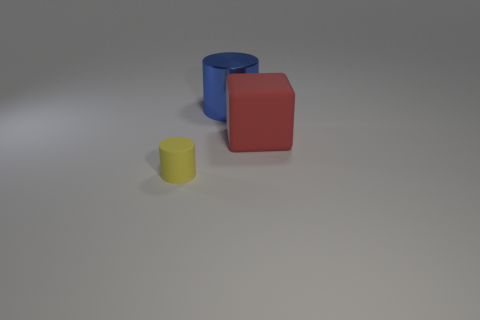Is the number of small yellow cylinders that are behind the yellow rubber cylinder greater than the number of large metal cylinders left of the metallic cylinder?
Provide a short and direct response. No. The other red object that is the same size as the shiny thing is what shape?
Provide a succinct answer. Cube. What number of things are either large green shiny cubes or matte objects behind the tiny yellow thing?
Give a very brief answer. 1. Is the large shiny cylinder the same color as the small cylinder?
Make the answer very short. No. There is a metallic cylinder; what number of blue shiny cylinders are in front of it?
Give a very brief answer. 0. There is a block that is made of the same material as the small yellow thing; what color is it?
Your answer should be compact. Red. What number of rubber objects are either big green spheres or big red blocks?
Your answer should be compact. 1. Is the red object made of the same material as the large blue object?
Ensure brevity in your answer.  No. What is the shape of the large thing that is to the left of the red matte object?
Make the answer very short. Cylinder. Are there any objects that are left of the large object on the right side of the blue cylinder?
Keep it short and to the point. Yes. 